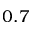Convert formula to latex. <formula><loc_0><loc_0><loc_500><loc_500>0 . 7</formula> 